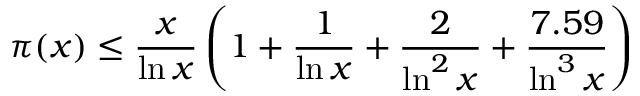<formula> <loc_0><loc_0><loc_500><loc_500>\pi ( x ) \leq { \frac { x } { \ln x } } \left ( 1 + { \frac { 1 } { \ln x } } + { \frac { 2 } { \ln ^ { 2 } x } } + { \frac { 7 . 5 9 } { \ln ^ { 3 } x } } \right )</formula> 